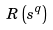<formula> <loc_0><loc_0><loc_500><loc_500>R \left ( { s } ^ { q } \right )</formula> 